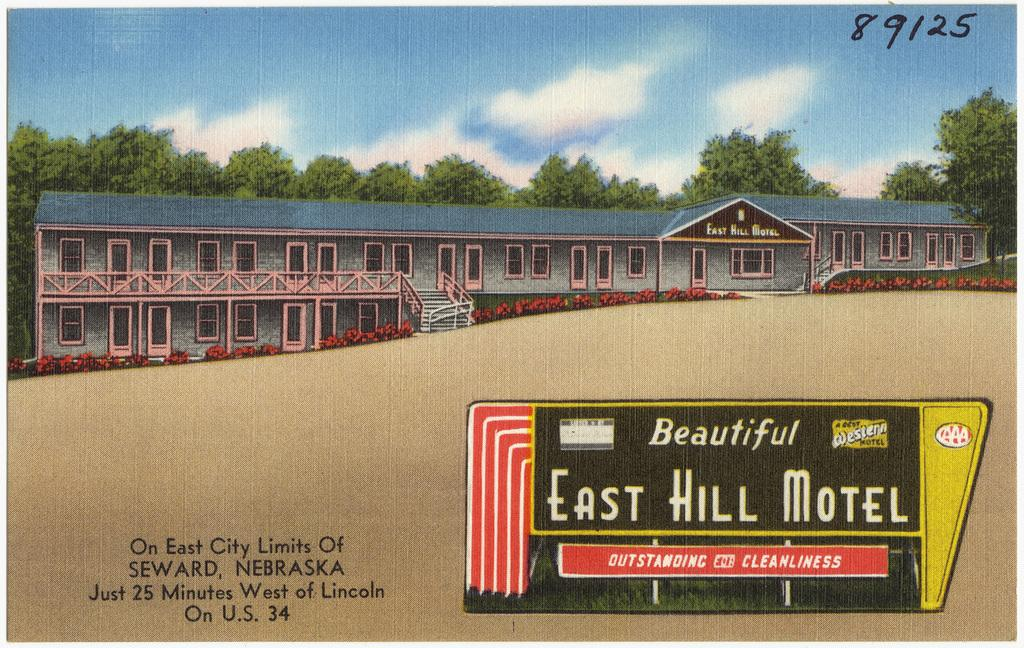<image>
Provide a brief description of the given image. A painting shows the East Hill Motel in the 80s. 